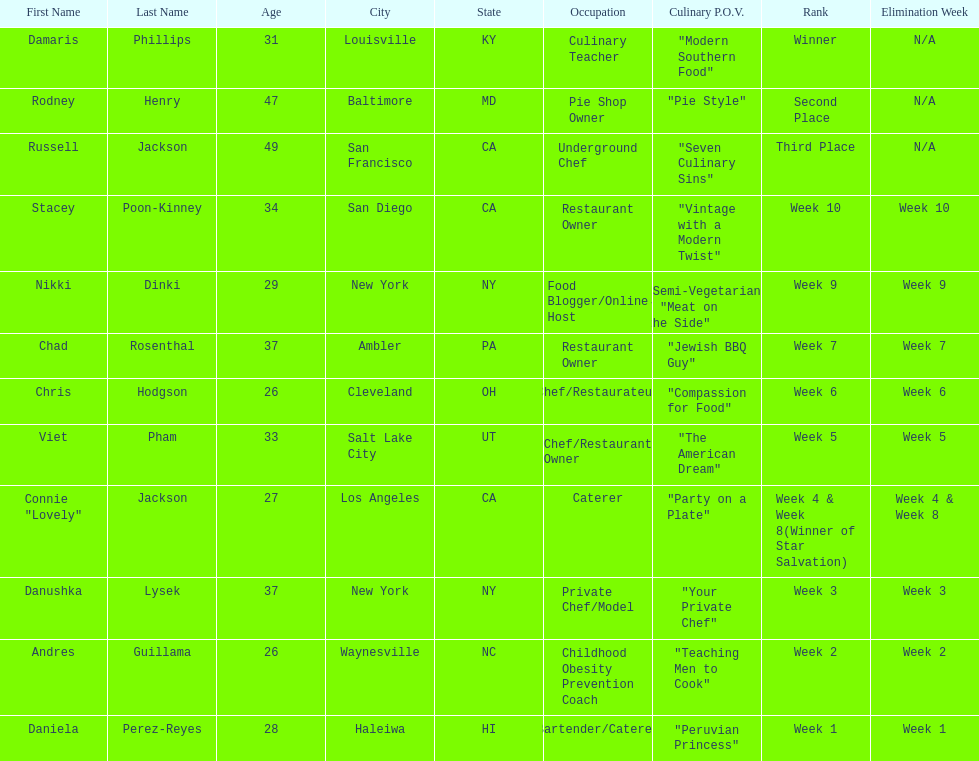Which competitor only lasted two weeks? Andres Guillama. 